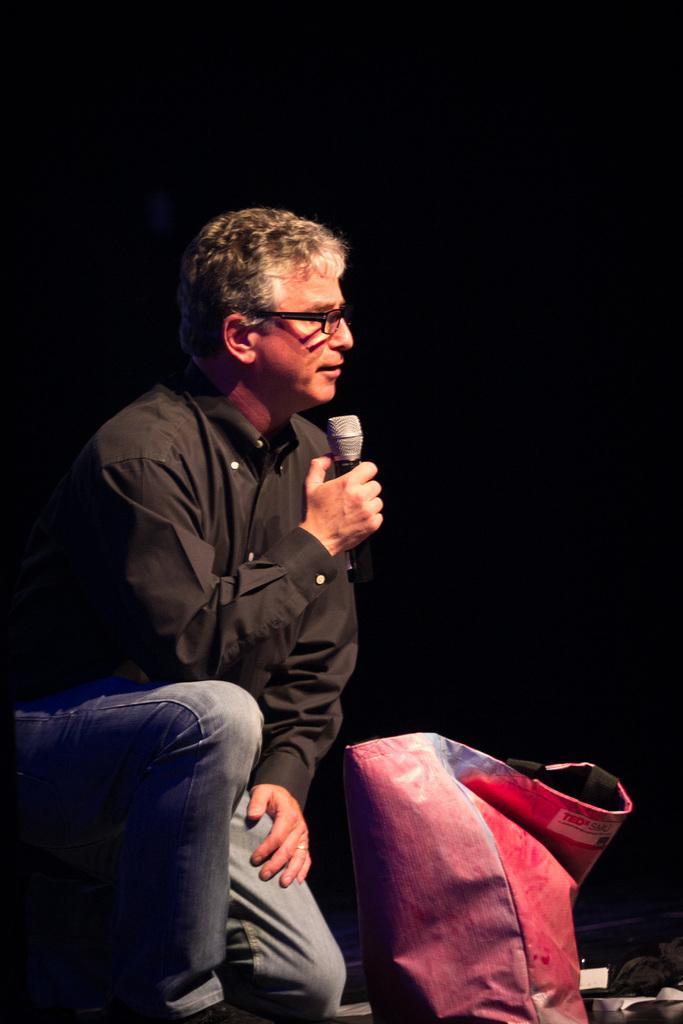Describe this image in one or two sentences. Here we can see a man is sitting on the floor, and holding a microphone in the hands, and here is the bag. 